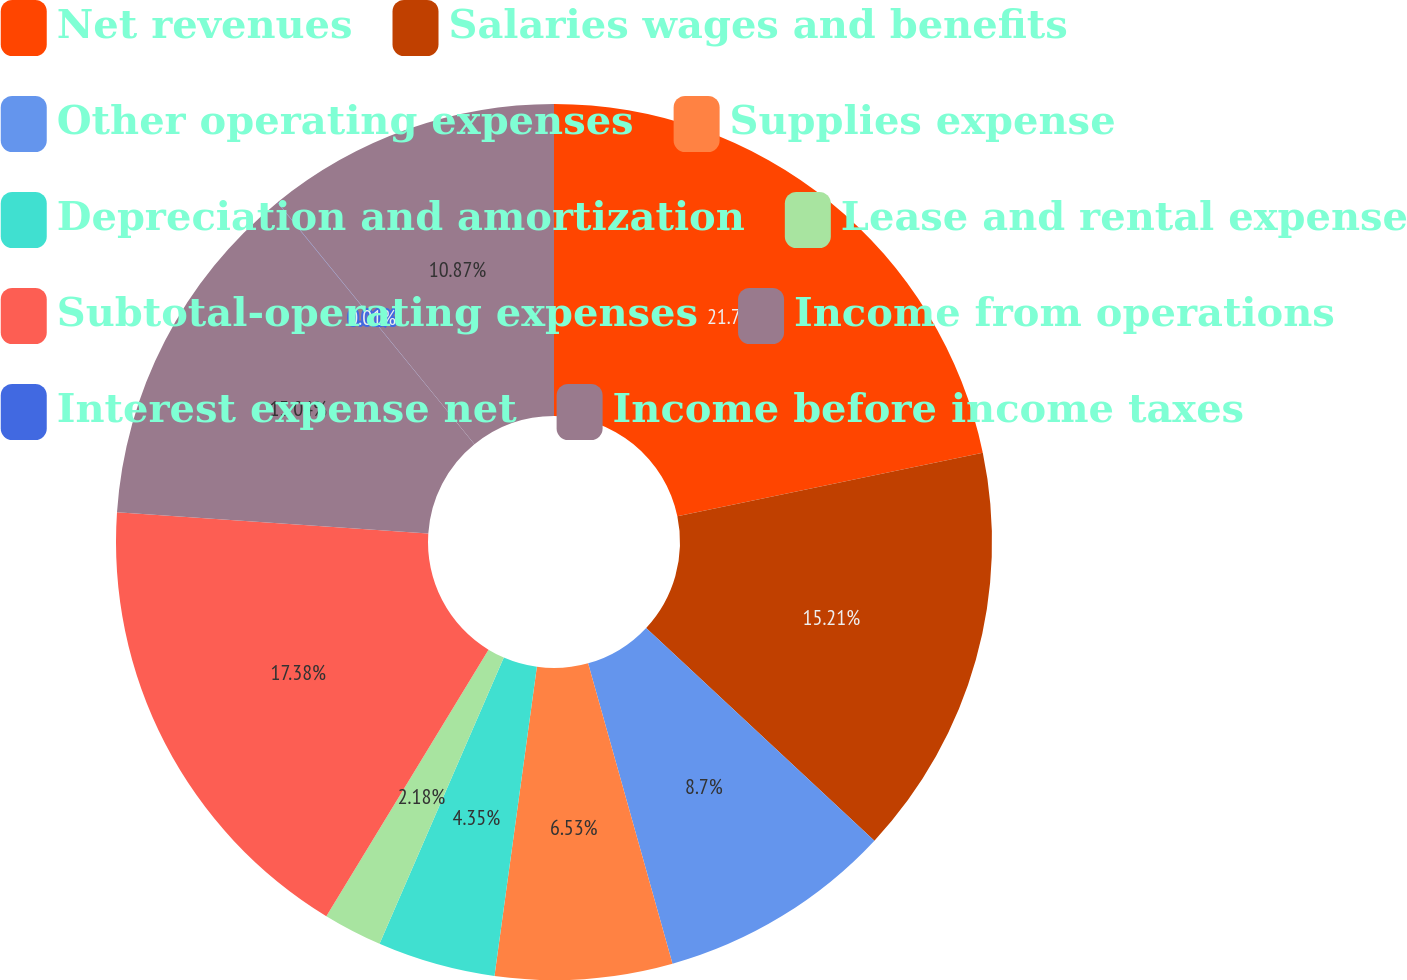<chart> <loc_0><loc_0><loc_500><loc_500><pie_chart><fcel>Net revenues<fcel>Salaries wages and benefits<fcel>Other operating expenses<fcel>Supplies expense<fcel>Depreciation and amortization<fcel>Lease and rental expense<fcel>Subtotal-operating expenses<fcel>Income from operations<fcel>Interest expense net<fcel>Income before income taxes<nl><fcel>21.73%<fcel>15.21%<fcel>8.7%<fcel>6.53%<fcel>4.35%<fcel>2.18%<fcel>17.38%<fcel>13.04%<fcel>0.01%<fcel>10.87%<nl></chart> 